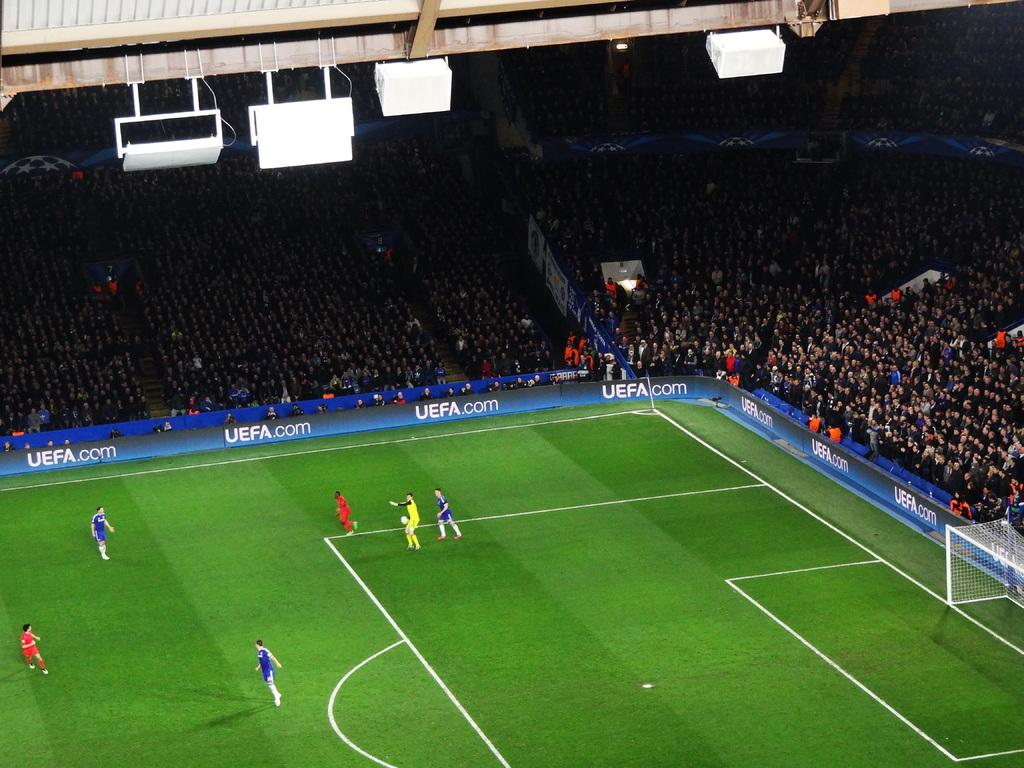<image>
Describe the image concisely. A statium overlooking a soccer game, with the UEFA.com on the banner 